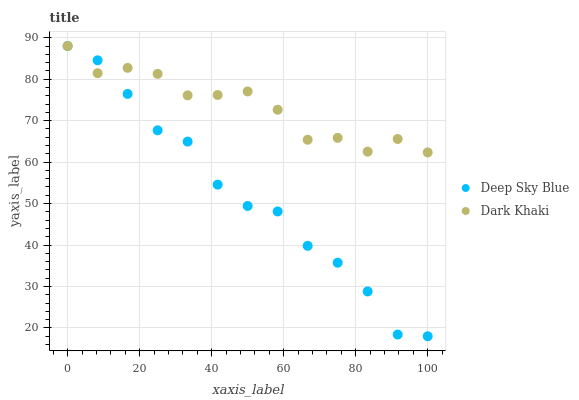Does Deep Sky Blue have the minimum area under the curve?
Answer yes or no. Yes. Does Dark Khaki have the maximum area under the curve?
Answer yes or no. Yes. Does Deep Sky Blue have the maximum area under the curve?
Answer yes or no. No. Is Dark Khaki the smoothest?
Answer yes or no. Yes. Is Deep Sky Blue the roughest?
Answer yes or no. Yes. Is Deep Sky Blue the smoothest?
Answer yes or no. No. Does Deep Sky Blue have the lowest value?
Answer yes or no. Yes. Does Deep Sky Blue have the highest value?
Answer yes or no. Yes. Does Deep Sky Blue intersect Dark Khaki?
Answer yes or no. Yes. Is Deep Sky Blue less than Dark Khaki?
Answer yes or no. No. Is Deep Sky Blue greater than Dark Khaki?
Answer yes or no. No. 